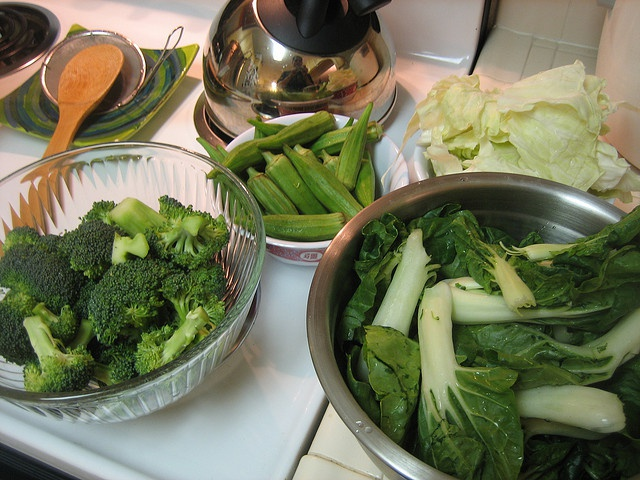Describe the objects in this image and their specific colors. I can see bowl in tan, black, darkgreen, and gray tones, broccoli in tan, black, darkgreen, and olive tones, bowl in tan, darkgreen, black, and olive tones, bowl in tan and khaki tones, and spoon in tan, orange, and red tones in this image. 